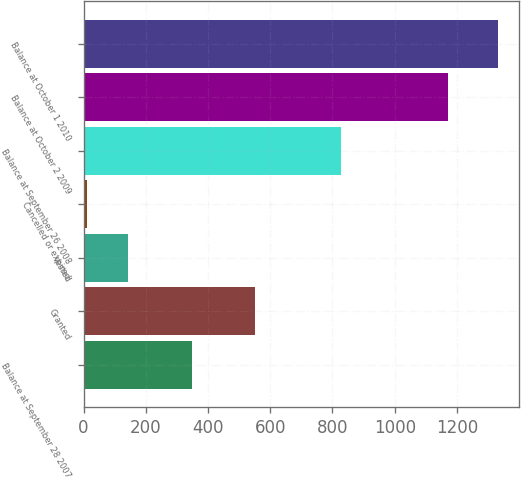Convert chart to OTSL. <chart><loc_0><loc_0><loc_500><loc_500><bar_chart><fcel>Balance at September 28 2007<fcel>Granted<fcel>Vested<fcel>Cancelled or expired<fcel>Balance at September 26 2008<fcel>Balance at October 2 2009<fcel>Balance at October 1 2010<nl><fcel>348<fcel>552<fcel>143.2<fcel>11<fcel>828<fcel>1172<fcel>1333<nl></chart> 